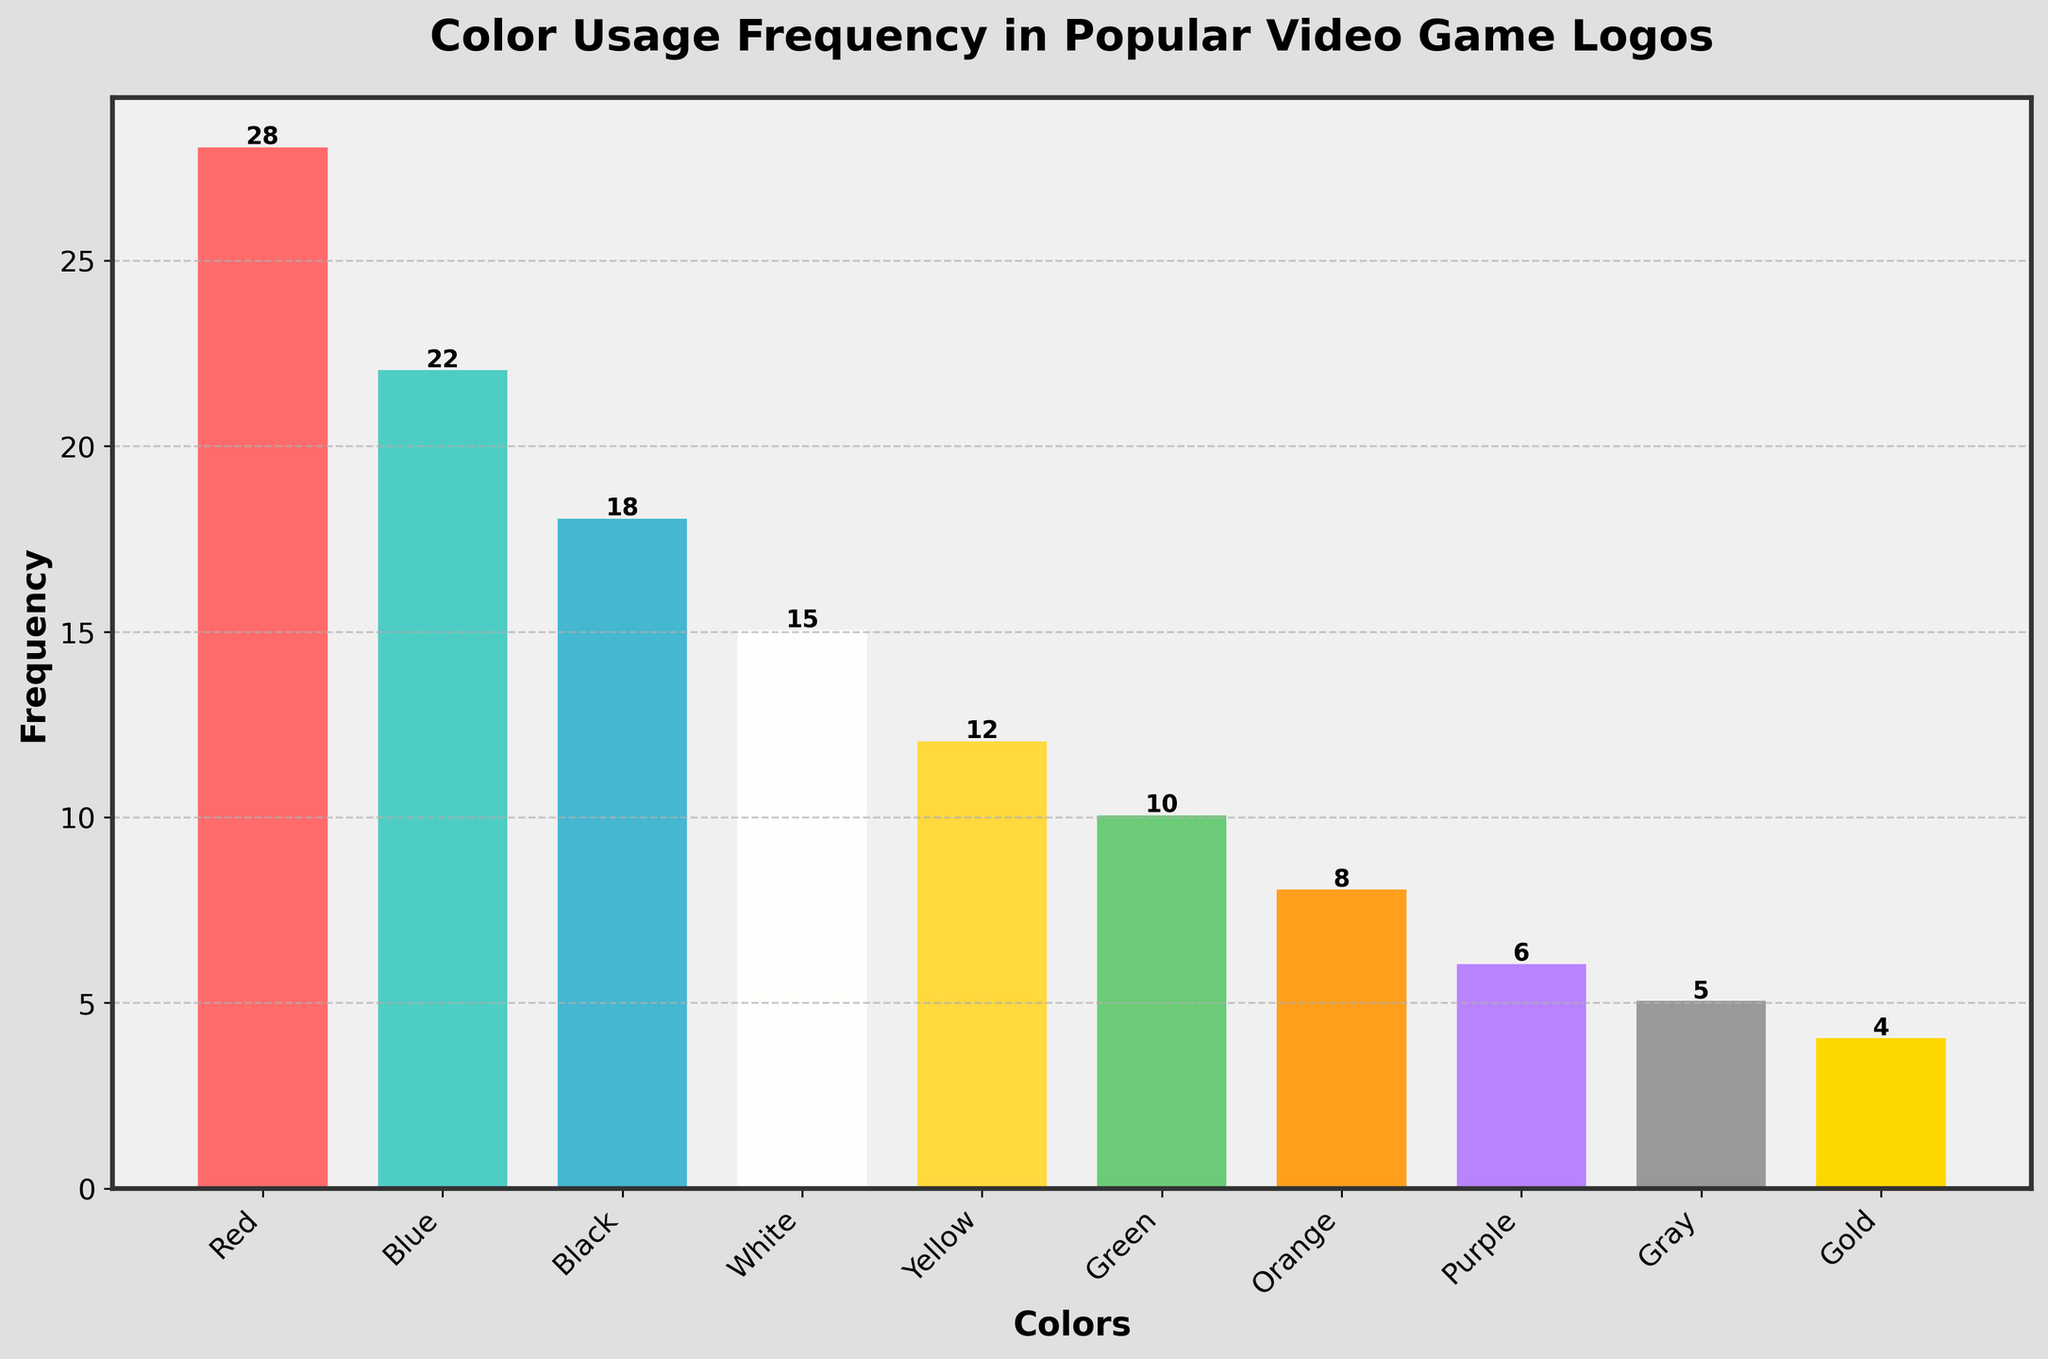What is the most frequently used color in popular video game logos? By looking at the height of the bars in the histogram, the tallest bar represents the most frequently used color. In this case, the tallest bar corresponds to the color Red, with a frequency of 28.
Answer: Red How many colors have a frequency of 10 or higher? To find this, count the number of bars that have a height of 10 or more. The colors with frequencies of 10 or higher are Red, Blue, Black, White, Yellow, and Green, which totals to six colors.
Answer: 6 Which color has the lowest frequency and what is it? By observing the heights of the bars, the shortest bar indicates the lowest frequency. The color Gold has the lowest frequency, with a count of 4.
Answer: Gold What is the combined frequency of Blue and Green? To find this, add the frequencies of Blue and Green, which are 22 and 10 respectively. Adding them together gives 22 + 10 = 32.
Answer: 32 Is the frequency of Yellow greater than that of Orange? Comparing the heights of the bars for Yellow and Orange, the height of the Yellow bar is 12, while the height of the Orange bar is 8. Thus, the frequency of Yellow is greater than that of Orange.
Answer: Yes What is the average frequency of the top three most used colors? Identify the top three bars (Red, Blue, and Black) with frequencies of 28, 22, and 18, respectively. To find the average, sum these values and divide by 3. The sum is 28 + 22 + 18 = 68, and the average is 68 / 3 ≈ 22.67.
Answer: 22.67 Which color is used exactly half as frequently as Blue? The frequency of Blue is 22, so half of this value is 11. By comparing with other bars, none of the bars exactly match a frequency of 11. Thus, no color is used exactly half as frequently as Blue.
Answer: None How does the frequency of Gray compare to that of Purple? From the histogram, the bars for Gray and Purple can be compared. Gray has a frequency of 5, while Purple has a frequency of 6. Thus, Gray is used less frequently than Purple.
Answer: Gray is less frequent How many colors are used more frequently than White? The frequency of White is 15. By counting the bars that are taller than the White bar, we find that four colors (Red, Blue, Black, and White itself) have higher frequencies, and Yellow is the same frequency or lower. Thus, four colors are used more frequently than White.
Answer: 4 What is the median frequency of the colors used? To find the median, list the frequencies in ascending order: 4, 5, 6, 8, 10, 12, 15, 18, 22, 28. The middle two numbers are 10 and 12, so the median is the average of these two values: (10 + 12) / 2 = 11.
Answer: 11 